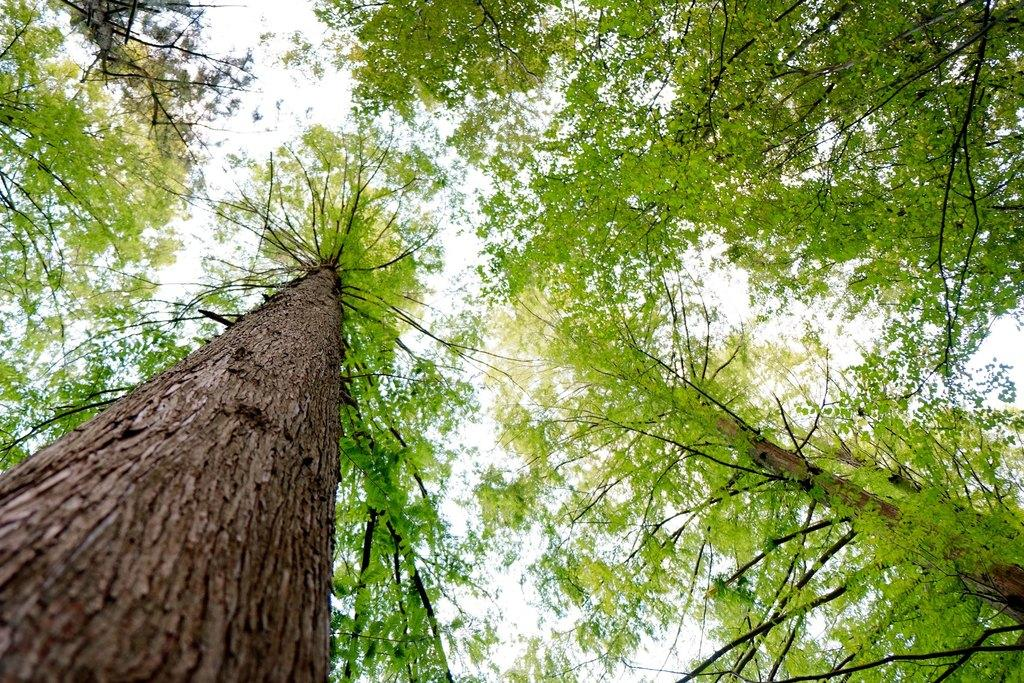What type of vegetation can be seen in the image? There are trees in the image. What part of the natural environment is visible in the image? The sky is visible in the background of the image. What type of shoes are hanging from the trees in the image? There are no shoes present in the image; it only features trees and the sky. 